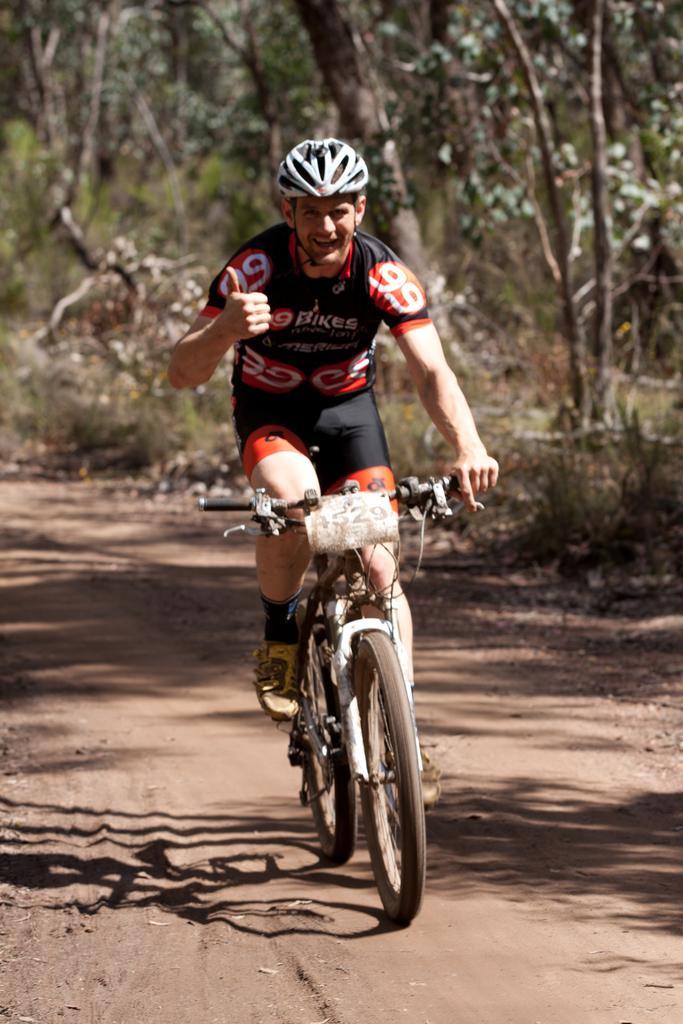Please provide a concise description of this image. In this picture we can see a man wore a helmet and riding a bicycle on the ground. In the background we can see trees. 